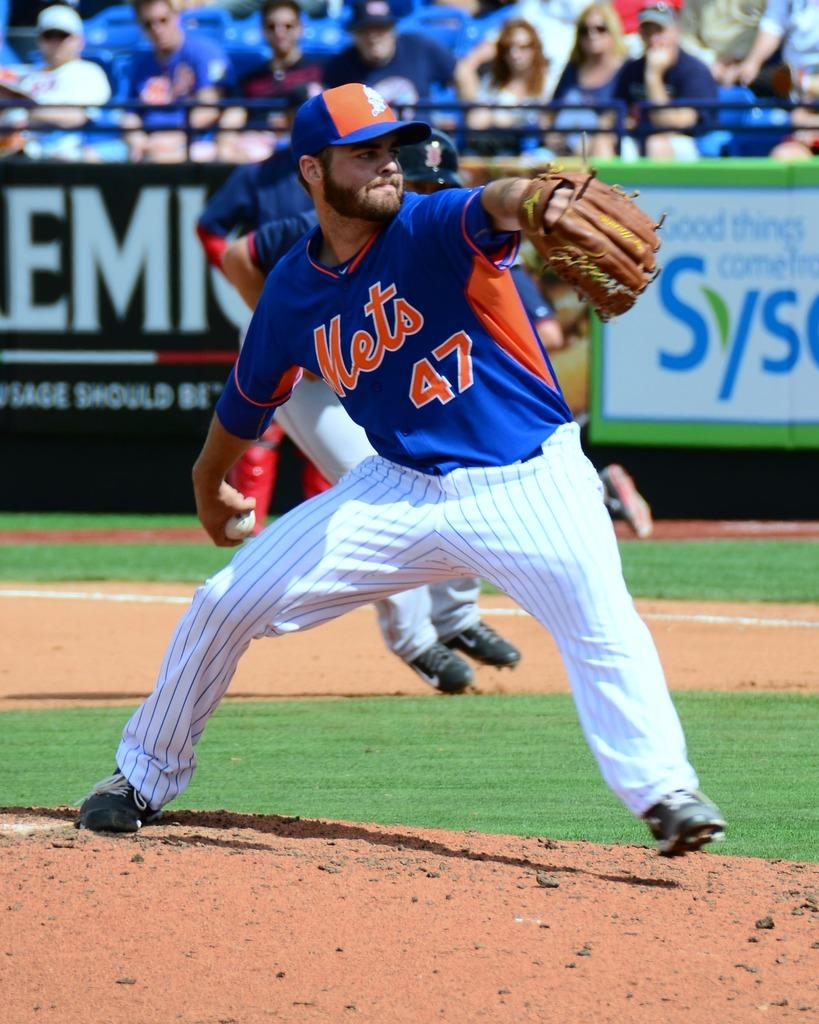<image>
Present a compact description of the photo's key features. a player that has the number 47 on their Mets jersey 